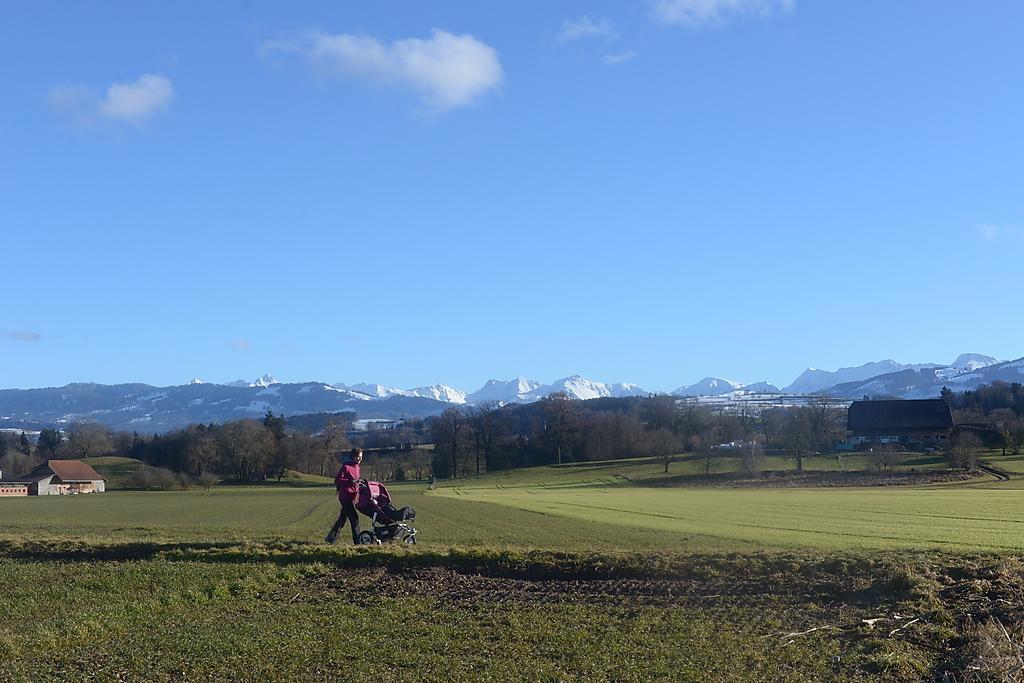Please provide a concise description of this image. In this image I can see the person with the dress and holding the stroller. The person is standing on the grass. In the background I can see the houses and many trees. In the background I can see the mountains, clouds and the sky. 